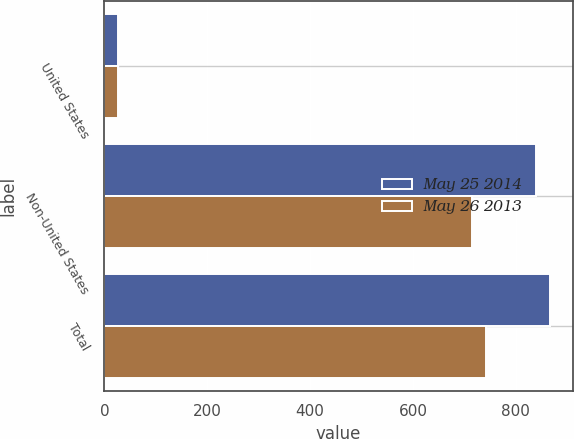Convert chart. <chart><loc_0><loc_0><loc_500><loc_500><stacked_bar_chart><ecel><fcel>United States<fcel>Non-United States<fcel>Total<nl><fcel>May 25 2014<fcel>27.2<fcel>840.1<fcel>867.3<nl><fcel>May 26 2013<fcel>26.9<fcel>714.5<fcel>741.4<nl></chart> 